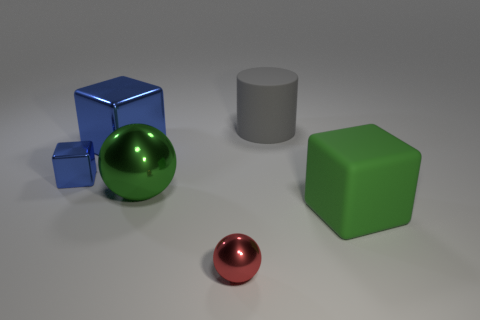How many green balls are left of the big cube that is on the left side of the rubber cylinder?
Provide a succinct answer. 0. There is a small object that is to the right of the tiny blue shiny thing; are there any tiny spheres that are on the left side of it?
Your answer should be very brief. No. There is a gray rubber thing; are there any rubber cubes behind it?
Make the answer very short. No. There is a tiny thing left of the small red thing; is its shape the same as the red object?
Your answer should be compact. No. How many other objects are the same shape as the big blue thing?
Offer a terse response. 2. Is there a gray cube that has the same material as the tiny blue block?
Make the answer very short. No. What is the material of the large green object that is left of the ball in front of the green block?
Make the answer very short. Metal. There is a metallic thing that is in front of the green block; how big is it?
Provide a succinct answer. Small. There is a tiny metallic cube; does it have the same color as the metallic block right of the small blue block?
Keep it short and to the point. Yes. Is there a big cylinder of the same color as the tiny shiny ball?
Give a very brief answer. No. 